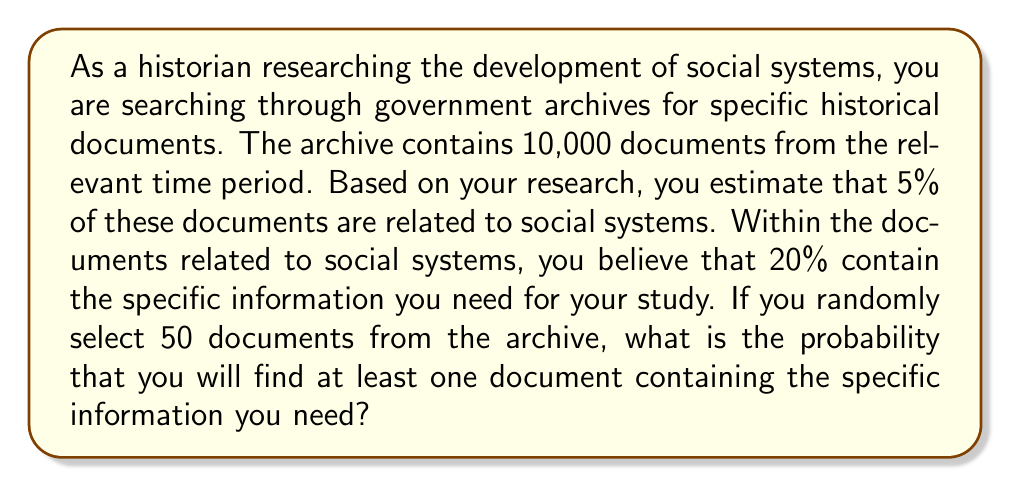Give your solution to this math problem. Let's approach this step-by-step:

1) First, let's calculate the probability of selecting a document with the specific information in a single draw:
   
   $P(\text{specific info}) = P(\text{social system}) \times P(\text{specific info | social system})$
   $= 0.05 \times 0.20 = 0.01$ or 1%

2) Now, we want to find the probability of getting at least one such document in 50 draws. It's easier to calculate the probability of not getting any such documents and then subtract from 1.

3) The probability of not getting a specific document in one draw is:
   
   $P(\text{not specific}) = 1 - 0.01 = 0.99$ or 99%

4) For all 50 draws to not have a specific document, this needs to happen 50 times in a row:
   
   $P(\text{no specific in 50 draws}) = 0.99^{50}$

5) We can calculate this:
   
   $0.99^{50} \approx 0.6052$

6) Therefore, the probability of getting at least one specific document is:
   
   $P(\text{at least one specific}) = 1 - P(\text{no specific in 50 draws})$
   $= 1 - 0.6052 = 0.3948$
Answer: The probability of finding at least one document containing the specific information needed in 50 random selections is approximately 0.3948 or 39.48%. 